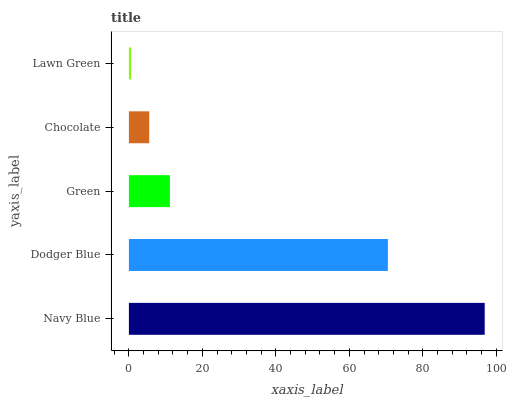Is Lawn Green the minimum?
Answer yes or no. Yes. Is Navy Blue the maximum?
Answer yes or no. Yes. Is Dodger Blue the minimum?
Answer yes or no. No. Is Dodger Blue the maximum?
Answer yes or no. No. Is Navy Blue greater than Dodger Blue?
Answer yes or no. Yes. Is Dodger Blue less than Navy Blue?
Answer yes or no. Yes. Is Dodger Blue greater than Navy Blue?
Answer yes or no. No. Is Navy Blue less than Dodger Blue?
Answer yes or no. No. Is Green the high median?
Answer yes or no. Yes. Is Green the low median?
Answer yes or no. Yes. Is Navy Blue the high median?
Answer yes or no. No. Is Lawn Green the low median?
Answer yes or no. No. 